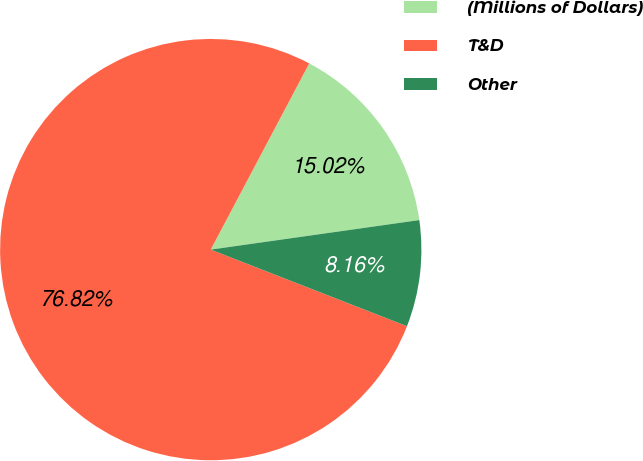<chart> <loc_0><loc_0><loc_500><loc_500><pie_chart><fcel>(Millions of Dollars)<fcel>T&D<fcel>Other<nl><fcel>15.02%<fcel>76.82%<fcel>8.16%<nl></chart> 